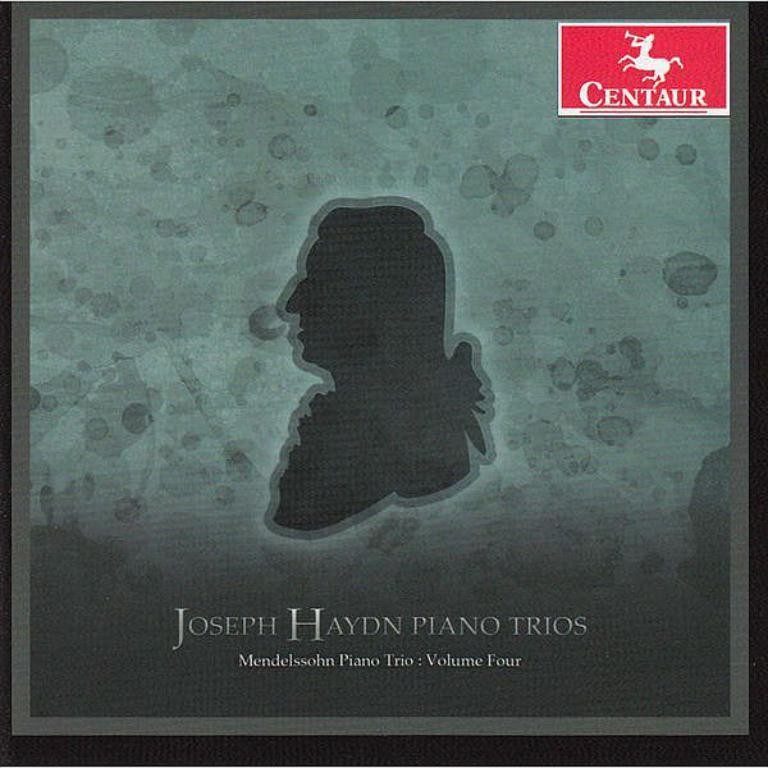<image>
Offer a succinct explanation of the picture presented. Album cover showing a shadow of a man's head and the name "Joseph Haydn" under it. 